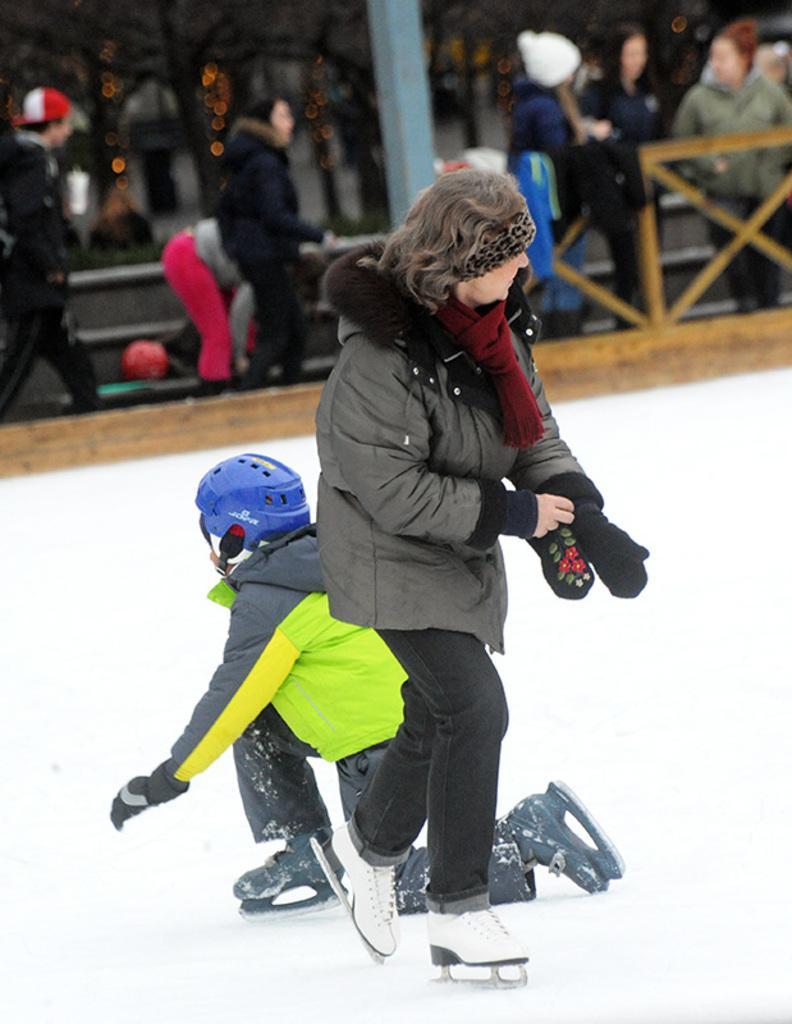Describe this image in one or two sentences. In the center of the image there are two people wearing jackets and gloves. At the bottom of the image there is white color surface. In the background of the image there are people. There is a wooden fencing. There is a pole. 